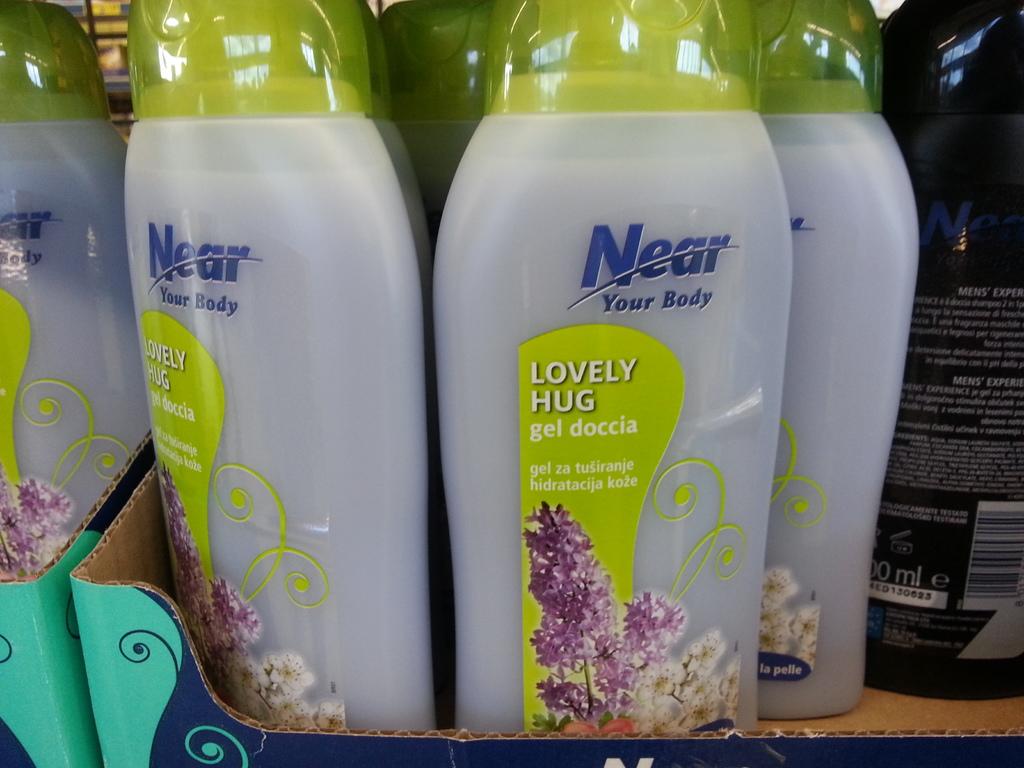What is the scent on the bottle?
Keep it short and to the point. Lovely hug. What does the top of the bottle say in blue?
Your response must be concise. Near. 